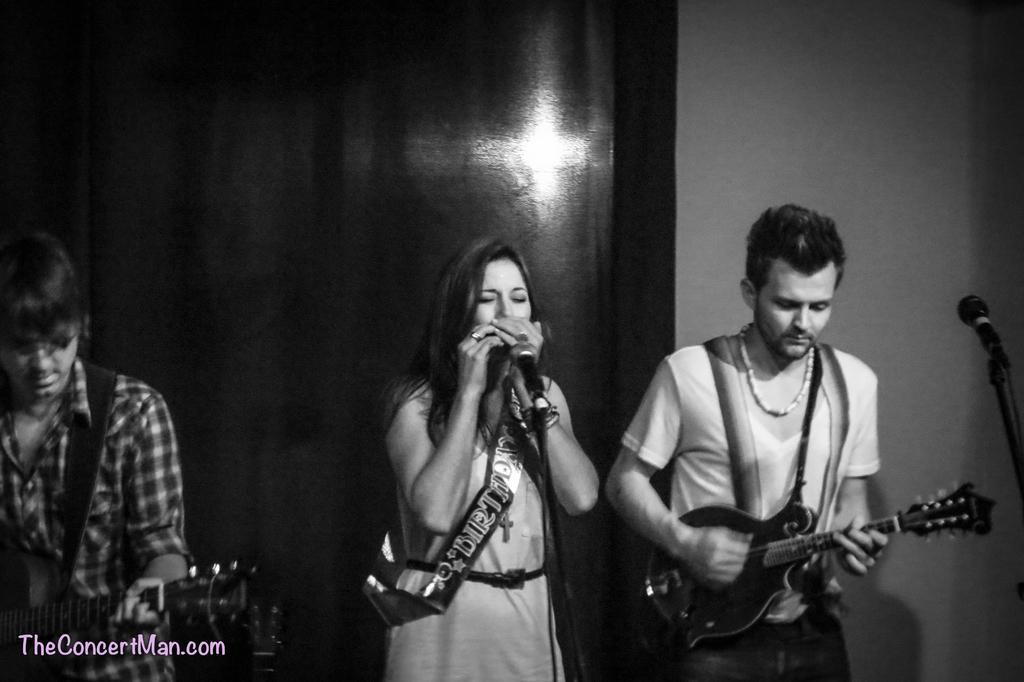Can you describe this image briefly? In this image In the middle there is a woman she is singing on the right there is a man he is playing guitar. On the left there is a man he wear check shirt and he is playing guitar. 